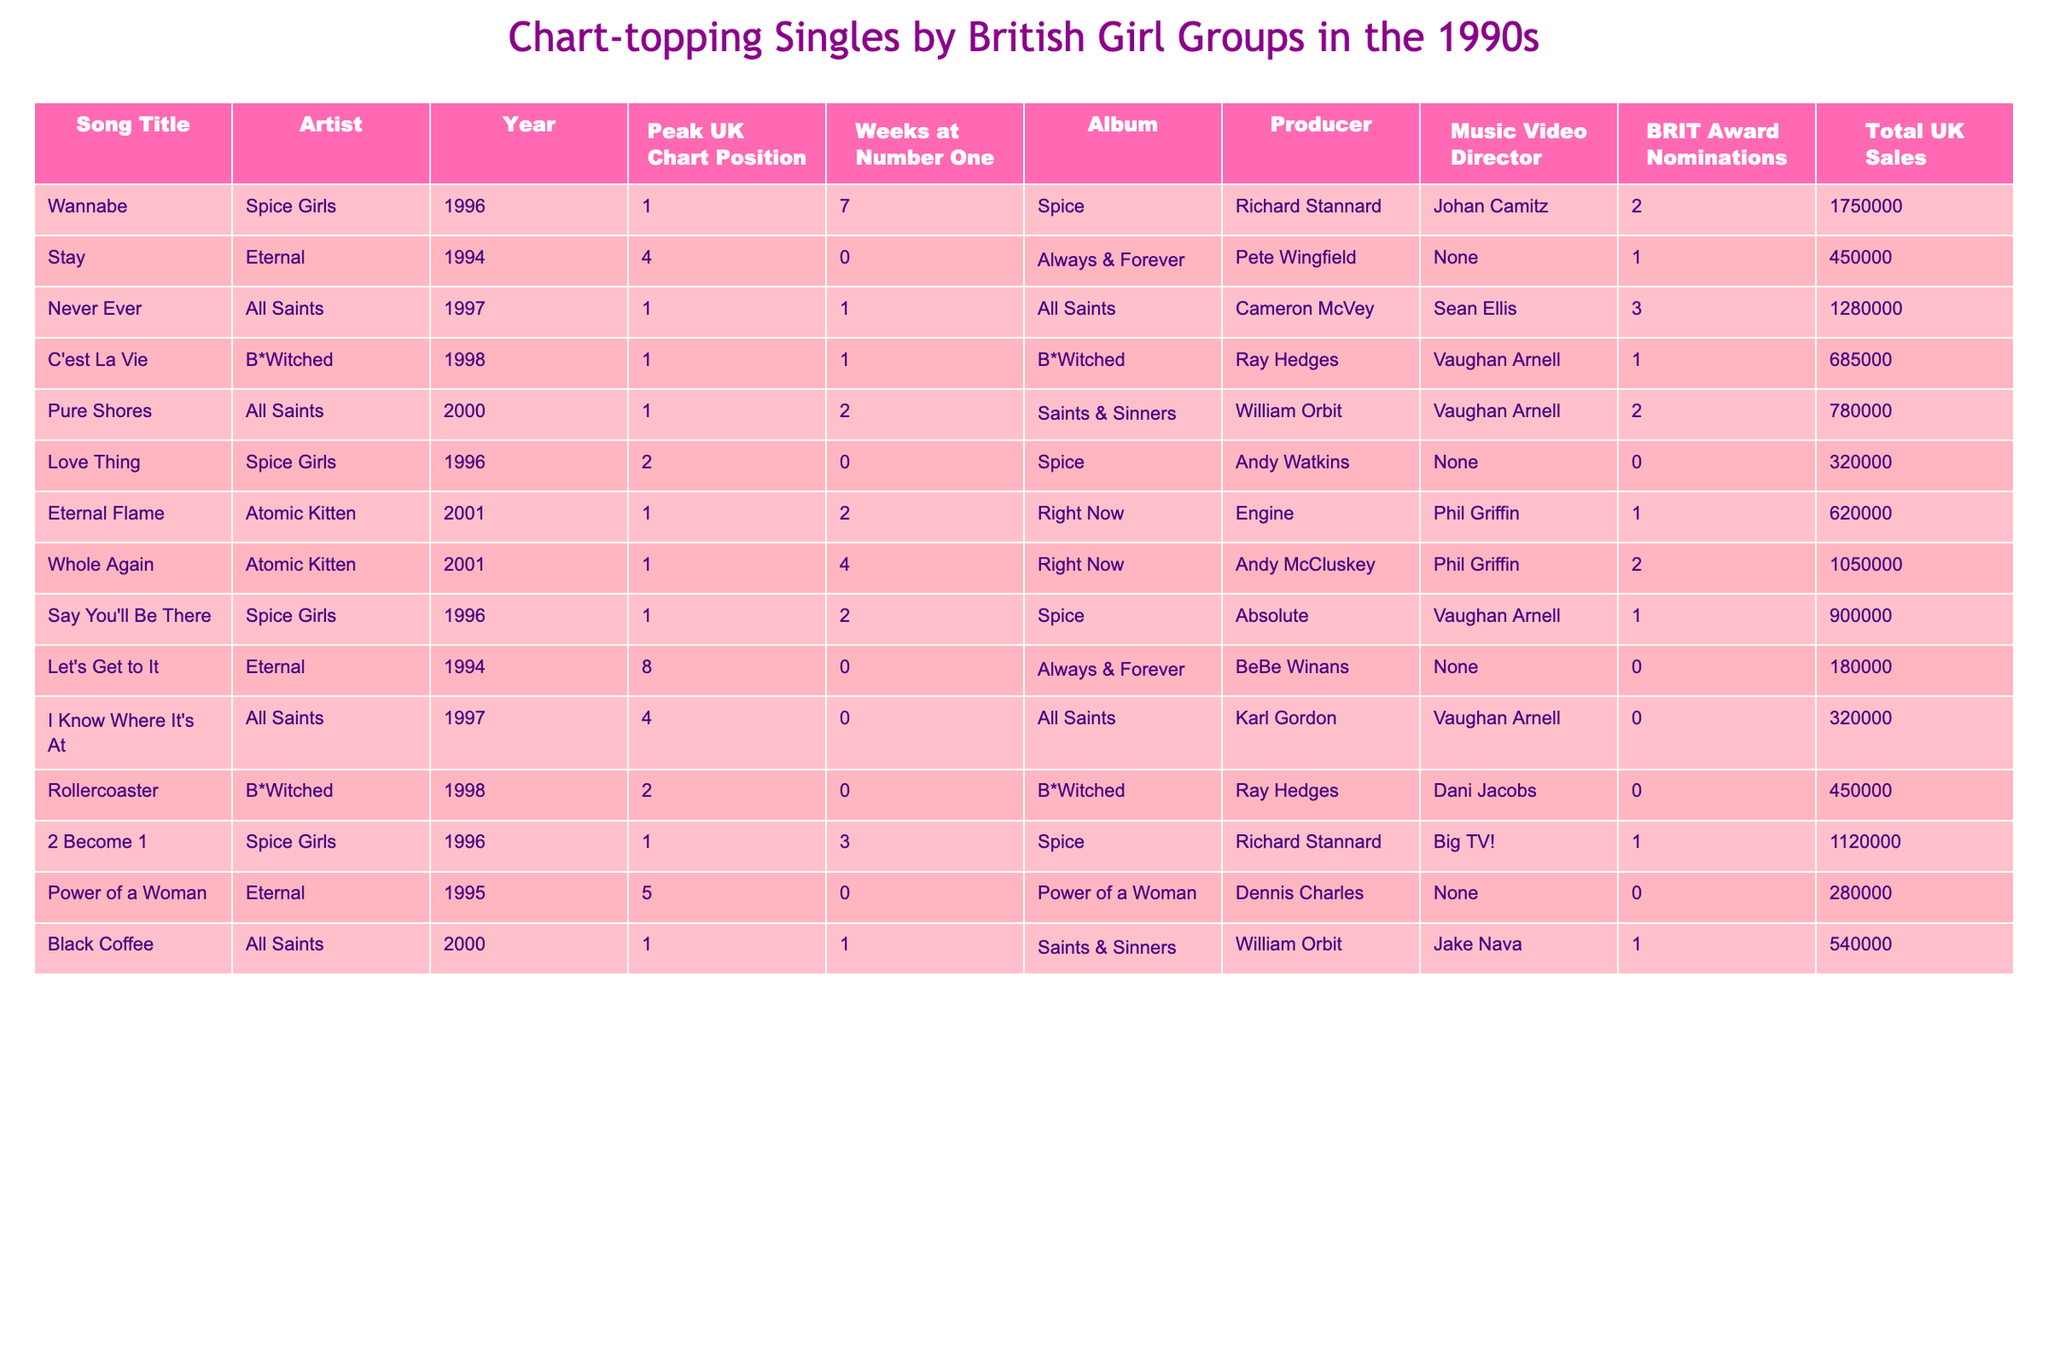What is the peak UK chart position of "Never Ever"? The table lists the song "Never Ever" by All Saints, and under the "Peak UK Chart Position" column, it shows 1.
Answer: 1 How many weeks did "Wannabe" stay at number one? According to the table, "Wannabe" by the Spice Girls stayed at number one for 7 weeks, as noted in the "Weeks at Number One" column.
Answer: 7 Which girl group had the most total UK sales? By checking the "Total UK Sales" column, "Wannabe" by the Spice Girls has the highest sales figure at 1,750,000.
Answer: Spice Girls Did "Stay" by Eternal have a peak chart position of 1? Referring to the table, "Stay" by Eternal peaked at position 4, not 1, so this statement is false.
Answer: False What is the average total UK sales for the songs listed in the table? The total sales are summed up: 1,750,000 + 450,000 + 1,280,000 + 685,000 + 780,000 + 900,000 + 1,120,000 + 280,000 + 620,000 + 540,000 = 7,485,000. There are 10 songs, so the average is 7,485,000 / 10 = 748,500.
Answer: 748,500 Which song from the 1996 has the highest UK sales? Looking at the table, "Wannabe" by the Spice Girls, released in 1996, has the highest sales of 1,750,000 compared to "Love Thing" at 320,000 and "Say You'll Be There" at 900,000.
Answer: Wannabe How many songs by the Spice Girls are listed in the table? By scanning the table, the songs by the Spice Girls are "Wannabe," "Love Thing," and "Say You'll Be There," giving a total of 3 songs.
Answer: 3 Which song had the most BRIT Award nominations? In the "BRIT Award Nominations" column, "Never Ever" by All Saints has the most with 3 nominations, as other songs have fewer or none.
Answer: Never Ever What is the difference in total UK sales between "2 Become 1" and "Power of a Woman"? "2 Become 1" has total sales of 1,120,000 and "Power of a Woman" has 280,000. Therefore, the difference is 1,120,000 - 280,000 = 840,000.
Answer: 840,000 Which song was directed by Phil Griffin? The table indicates that both "Eternal Flame" and "Whole Again" were directed by Phil Griffin, as seen in the "Music Video Director" column.
Answer: Eternal Flame and Whole Again 